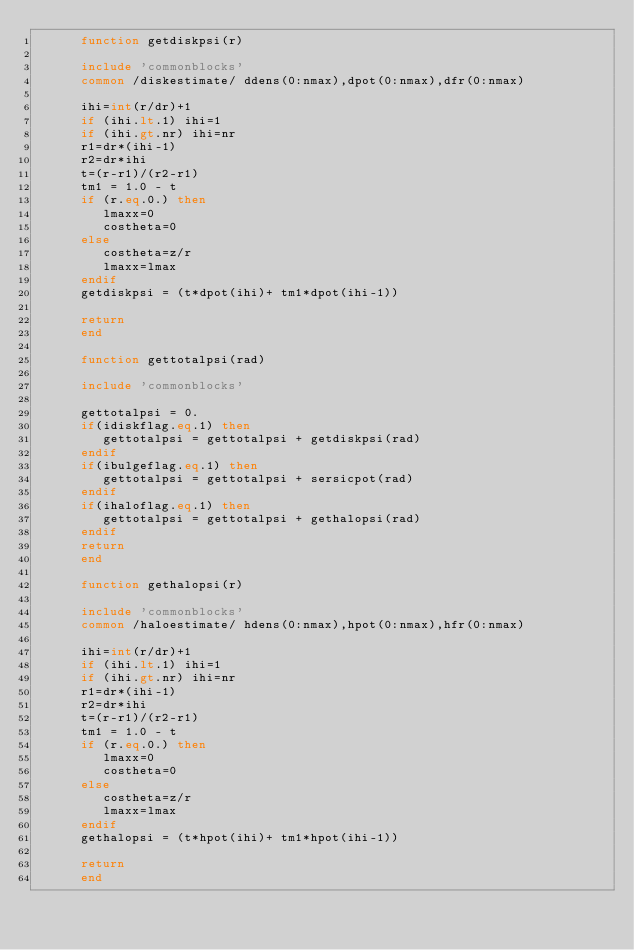<code> <loc_0><loc_0><loc_500><loc_500><_FORTRAN_>      function getdiskpsi(r)

      include 'commonblocks'
      common /diskestimate/ ddens(0:nmax),dpot(0:nmax),dfr(0:nmax)

      ihi=int(r/dr)+1
      if (ihi.lt.1) ihi=1
      if (ihi.gt.nr) ihi=nr
      r1=dr*(ihi-1)
      r2=dr*ihi
      t=(r-r1)/(r2-r1)
      tm1 = 1.0 - t
      if (r.eq.0.) then
         lmaxx=0
         costheta=0
      else
         costheta=z/r
         lmaxx=lmax
      endif
      getdiskpsi = (t*dpot(ihi)+ tm1*dpot(ihi-1))

      return
      end

      function gettotalpsi(rad)

      include 'commonblocks'

      gettotalpsi = 0.
      if(idiskflag.eq.1) then
         gettotalpsi = gettotalpsi + getdiskpsi(rad)
      endif
      if(ibulgeflag.eq.1) then
         gettotalpsi = gettotalpsi + sersicpot(rad)
      endif
      if(ihaloflag.eq.1) then
         gettotalpsi = gettotalpsi + gethalopsi(rad)
      endif
      return
      end

      function gethalopsi(r)

      include 'commonblocks'
      common /haloestimate/ hdens(0:nmax),hpot(0:nmax),hfr(0:nmax)

      ihi=int(r/dr)+1
      if (ihi.lt.1) ihi=1
      if (ihi.gt.nr) ihi=nr
      r1=dr*(ihi-1)
      r2=dr*ihi
      t=(r-r1)/(r2-r1)
      tm1 = 1.0 - t
      if (r.eq.0.) then
         lmaxx=0
         costheta=0
      else
         costheta=z/r
         lmaxx=lmax
      endif
      gethalopsi = (t*hpot(ihi)+ tm1*hpot(ihi-1))

      return
      end



</code> 